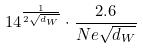Convert formula to latex. <formula><loc_0><loc_0><loc_500><loc_500>1 4 ^ { \frac { 1 } { 2 \sqrt { d _ { W } } } } \cdot \frac { 2 . 6 } { N e \sqrt { d _ { W } } }</formula> 